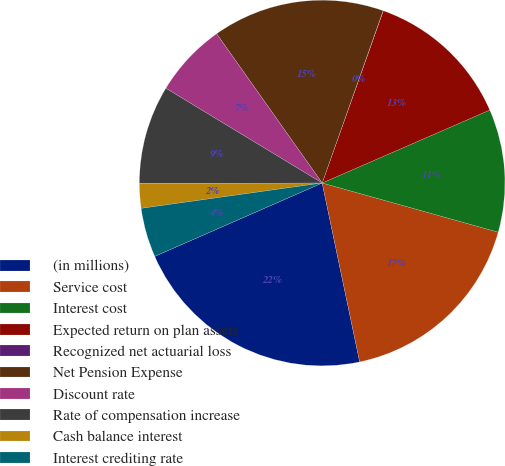Convert chart. <chart><loc_0><loc_0><loc_500><loc_500><pie_chart><fcel>(in millions)<fcel>Service cost<fcel>Interest cost<fcel>Expected return on plan assets<fcel>Recognized net actuarial loss<fcel>Net Pension Expense<fcel>Discount rate<fcel>Rate of compensation increase<fcel>Cash balance interest<fcel>Interest crediting rate<nl><fcel>21.72%<fcel>17.38%<fcel>10.87%<fcel>13.04%<fcel>0.02%<fcel>15.21%<fcel>6.53%<fcel>8.7%<fcel>2.19%<fcel>4.36%<nl></chart> 